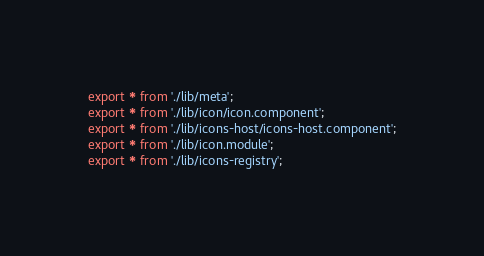Convert code to text. <code><loc_0><loc_0><loc_500><loc_500><_TypeScript_>export * from './lib/meta';
export * from './lib/icon/icon.component';
export * from './lib/icons-host/icons-host.component';
export * from './lib/icon.module';
export * from './lib/icons-registry';
</code> 